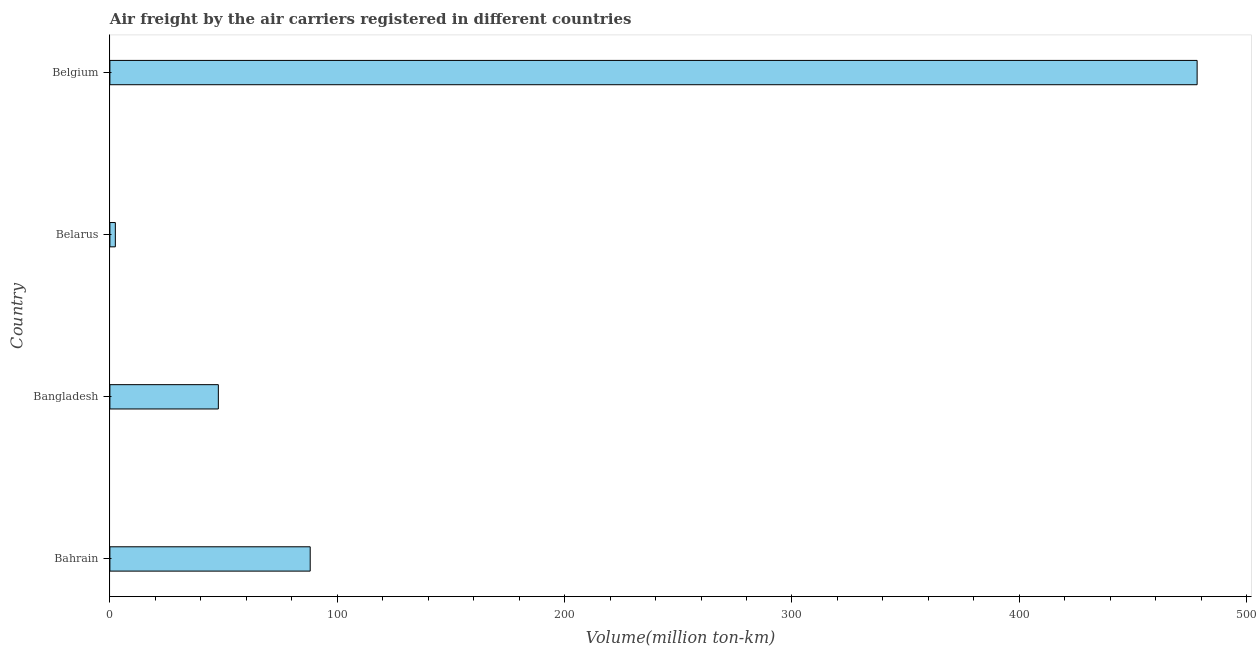Does the graph contain any zero values?
Your answer should be very brief. No. Does the graph contain grids?
Give a very brief answer. No. What is the title of the graph?
Make the answer very short. Air freight by the air carriers registered in different countries. What is the label or title of the X-axis?
Your answer should be very brief. Volume(million ton-km). What is the label or title of the Y-axis?
Offer a terse response. Country. What is the air freight in Bangladesh?
Provide a succinct answer. 47.7. Across all countries, what is the maximum air freight?
Offer a terse response. 478.2. Across all countries, what is the minimum air freight?
Your response must be concise. 2.4. In which country was the air freight maximum?
Offer a terse response. Belgium. In which country was the air freight minimum?
Your answer should be very brief. Belarus. What is the sum of the air freight?
Your answer should be compact. 616.4. What is the difference between the air freight in Bangladesh and Belarus?
Your answer should be very brief. 45.3. What is the average air freight per country?
Offer a terse response. 154.1. What is the median air freight?
Provide a short and direct response. 67.9. In how many countries, is the air freight greater than 60 million ton-km?
Provide a short and direct response. 2. What is the ratio of the air freight in Bahrain to that in Belgium?
Provide a short and direct response. 0.18. Is the air freight in Bahrain less than that in Belgium?
Your answer should be compact. Yes. What is the difference between the highest and the second highest air freight?
Your answer should be very brief. 390.1. Is the sum of the air freight in Bahrain and Belgium greater than the maximum air freight across all countries?
Provide a short and direct response. Yes. What is the difference between the highest and the lowest air freight?
Ensure brevity in your answer.  475.8. How many bars are there?
Provide a short and direct response. 4. Are all the bars in the graph horizontal?
Keep it short and to the point. Yes. How many countries are there in the graph?
Offer a terse response. 4. What is the difference between two consecutive major ticks on the X-axis?
Give a very brief answer. 100. What is the Volume(million ton-km) in Bahrain?
Offer a terse response. 88.1. What is the Volume(million ton-km) of Bangladesh?
Keep it short and to the point. 47.7. What is the Volume(million ton-km) of Belarus?
Your answer should be compact. 2.4. What is the Volume(million ton-km) in Belgium?
Provide a short and direct response. 478.2. What is the difference between the Volume(million ton-km) in Bahrain and Bangladesh?
Keep it short and to the point. 40.4. What is the difference between the Volume(million ton-km) in Bahrain and Belarus?
Offer a terse response. 85.7. What is the difference between the Volume(million ton-km) in Bahrain and Belgium?
Offer a very short reply. -390.1. What is the difference between the Volume(million ton-km) in Bangladesh and Belarus?
Provide a short and direct response. 45.3. What is the difference between the Volume(million ton-km) in Bangladesh and Belgium?
Offer a terse response. -430.5. What is the difference between the Volume(million ton-km) in Belarus and Belgium?
Keep it short and to the point. -475.8. What is the ratio of the Volume(million ton-km) in Bahrain to that in Bangladesh?
Your answer should be very brief. 1.85. What is the ratio of the Volume(million ton-km) in Bahrain to that in Belarus?
Your response must be concise. 36.71. What is the ratio of the Volume(million ton-km) in Bahrain to that in Belgium?
Your response must be concise. 0.18. What is the ratio of the Volume(million ton-km) in Bangladesh to that in Belarus?
Make the answer very short. 19.88. What is the ratio of the Volume(million ton-km) in Bangladesh to that in Belgium?
Your response must be concise. 0.1. What is the ratio of the Volume(million ton-km) in Belarus to that in Belgium?
Your response must be concise. 0.01. 